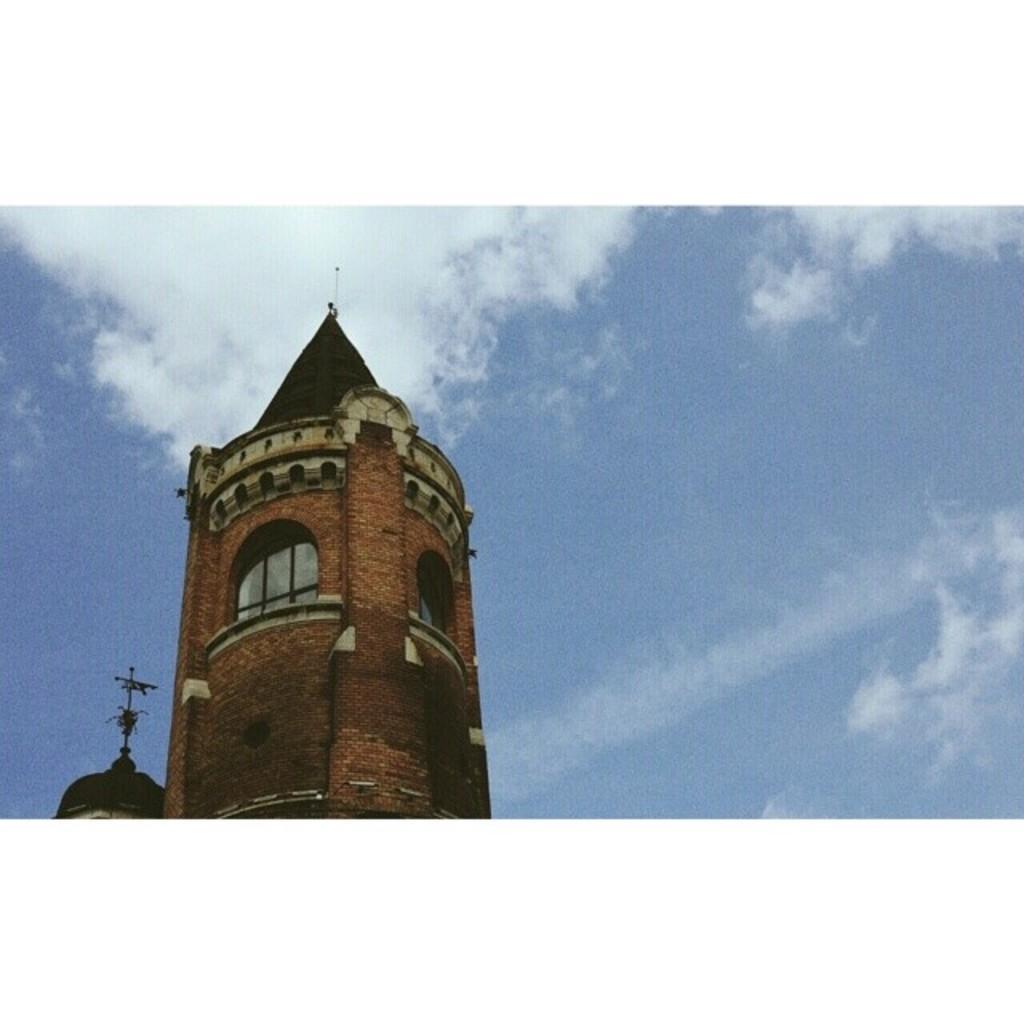Describe this image in one or two sentences. In the image we can see there are buildings and there is a cloudy sky. The building is made up of red bricks. 